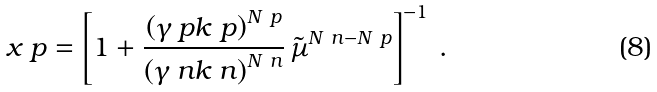<formula> <loc_0><loc_0><loc_500><loc_500>x _ { \ } p = \left [ 1 + \frac { \left ( \gamma _ { \ } p k _ { \ } p \right ) ^ { N _ { \ } p } } { \left ( \gamma _ { \ } n k _ { \ } n \right ) ^ { N _ { \ } n } } \, \tilde { \mu } ^ { N _ { \ } n - N _ { \ } p } \right ] ^ { - 1 } \, .</formula> 